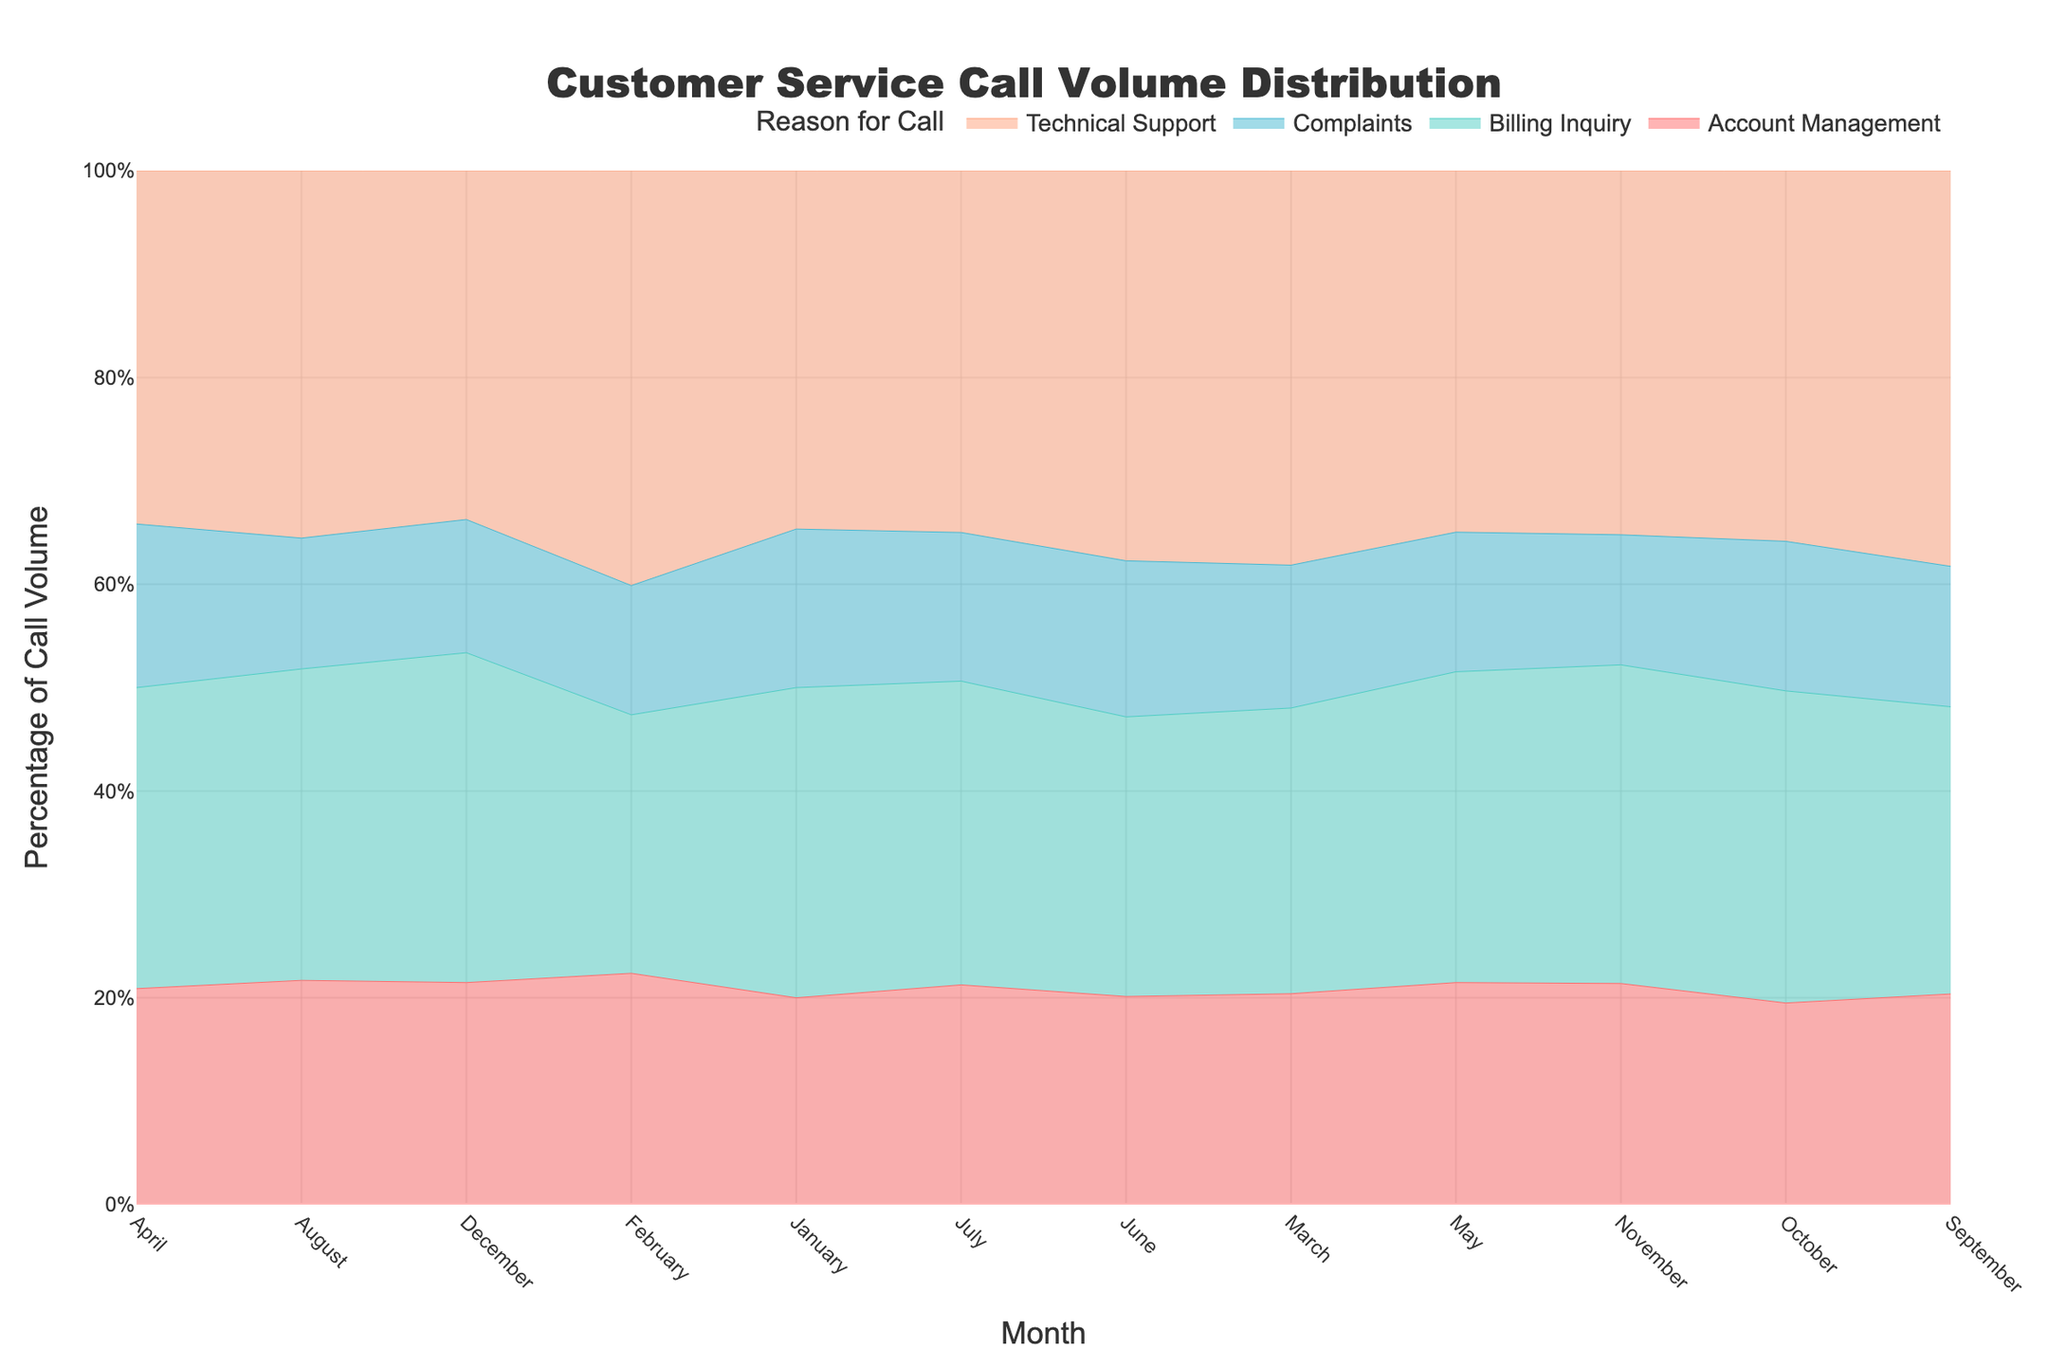What is the title of the figure? The title is prominently displayed at the top of the figure and reads "Customer Service Call Volume Distribution".
Answer: Customer Service Call Volume Distribution How is the percentage of call volume represented on the y-axis? The y-axis label indicates "Percentage of Call Volume" and the axis is marked with percentage values from 0% to 100%.
Answer: Percentage Which month had the highest total call volume for Billing Inquiry? By observing the height of the stream for Billing Inquiry across different months, December reaches the peak.
Answer: December Which category of call had the most consistent volume throughout the year? By comparing the streamlines, Account Management shows a relatively consistent height across all months indicating consistent call volume.
Answer: Account Management How does the call volume for Technical Support in January compare to that in September? The stream for Technical Support in January is slightly lower than in September, indicating a smaller percentage of call volume.
Answer: Lower in January In which month did Complaints calls make up the smallest percentage of total calls? By observing the streams, Complaints in February shows the lowest height indicating the smallest percentage of total calls.
Answer: February What is the total percentage of call volumes made up by Billing Inquiry and Technical Support in August? Adding the percentage contribution of Billing Inquiry and Technical Support streams in August shown on the y-axis, it sums up to approximately 50% + 30% = 80%.
Answer: 80% Which month had the highest percentage of call volume for combined Billing Inquiry and Account Management inquiries? Across all months, April's combined streams for Billing Inquiry and Account Management appear to be the highest.
Answer: April How does the trend in call volumes for Complaints change from May to December? By following the stream for Complaints from May to December, it fluctuates but generally decreases towards the end of the year.
Answer: Decreases What is the average percentage of call volume for Complaints across all months? Observing the stream for Complaints, eyeball roughly each month's contribution and average them out (e.g., 8.7% + 6.4% + ... etc.), summing up to an average around 7%.
Answer: 7% 